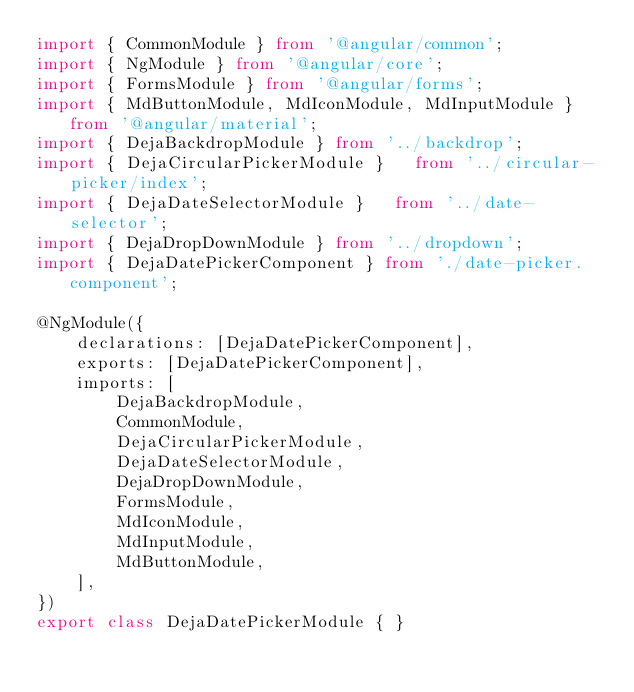Convert code to text. <code><loc_0><loc_0><loc_500><loc_500><_TypeScript_>import { CommonModule } from '@angular/common';
import { NgModule } from '@angular/core';
import { FormsModule } from '@angular/forms';
import { MdButtonModule, MdIconModule, MdInputModule } from '@angular/material';
import { DejaBackdropModule } from '../backdrop';
import { DejaCircularPickerModule }   from '../circular-picker/index';
import { DejaDateSelectorModule }   from '../date-selector';
import { DejaDropDownModule } from '../dropdown';
import { DejaDatePickerComponent } from './date-picker.component';

@NgModule({
    declarations: [DejaDatePickerComponent],
    exports: [DejaDatePickerComponent],
    imports: [
        DejaBackdropModule,
        CommonModule,
        DejaCircularPickerModule,
        DejaDateSelectorModule,
        DejaDropDownModule,
        FormsModule,
        MdIconModule,
        MdInputModule,
        MdButtonModule,
    ],
})
export class DejaDatePickerModule { }
</code> 